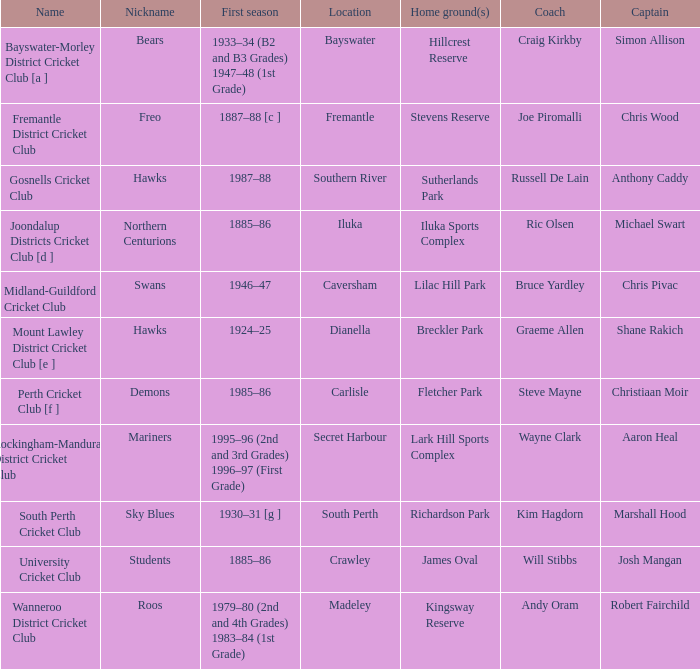What is the code alias for the initiative coached by steve mayne? Demons. 